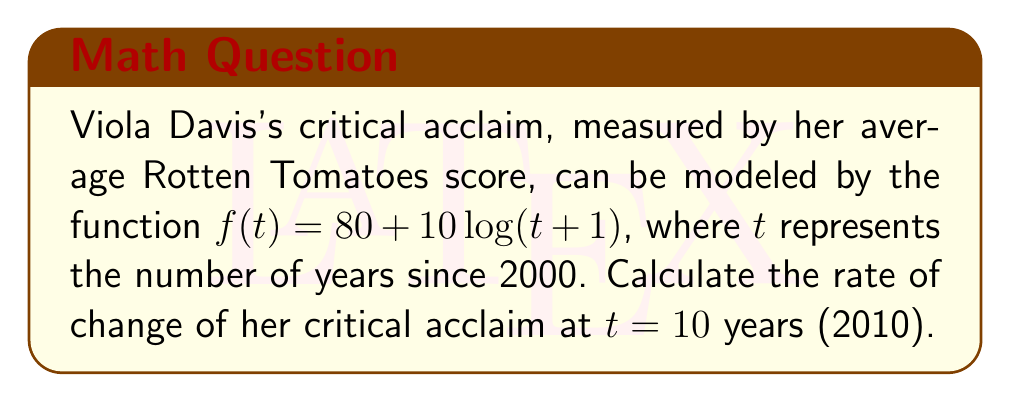Teach me how to tackle this problem. To find the rate of change of Viola Davis's critical acclaim at $t = 10$, we need to differentiate the given function and evaluate it at $t = 10$.

1. Given function: $f(t) = 80 + 10\log(t+1)$

2. To find the derivative, we use the chain rule:
   $$\frac{d}{dt}[f(t)] = \frac{d}{dt}[80] + \frac{d}{dt}[10\log(t+1)]$$
   $$f'(t) = 0 + 10 \cdot \frac{d}{dt}[\log(t+1)]$$
   $$f'(t) = 10 \cdot \frac{1}{t+1}$$

3. Simplify:
   $$f'(t) = \frac{10}{t+1}$$

4. Evaluate at $t = 10$:
   $$f'(10) = \frac{10}{10+1} = \frac{10}{11}$$

5. Convert to decimal:
   $$f'(10) \approx 0.9091$$
Answer: The rate of change of Viola Davis's critical acclaim in 2010 (10 years after 2000) is approximately 0.9091 Rotten Tomatoes score points per year. 